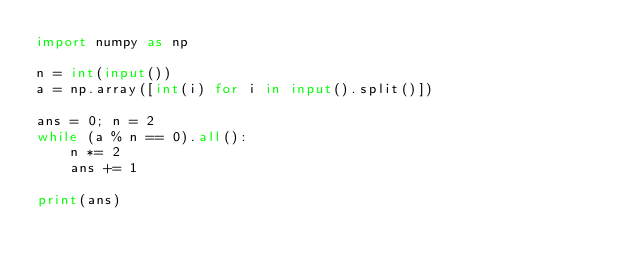<code> <loc_0><loc_0><loc_500><loc_500><_Python_>import numpy as np

n = int(input())
a = np.array([int(i) for i in input().split()])

ans = 0; n = 2
while (a % n == 0).all():
    n *= 2
    ans += 1

print(ans)</code> 